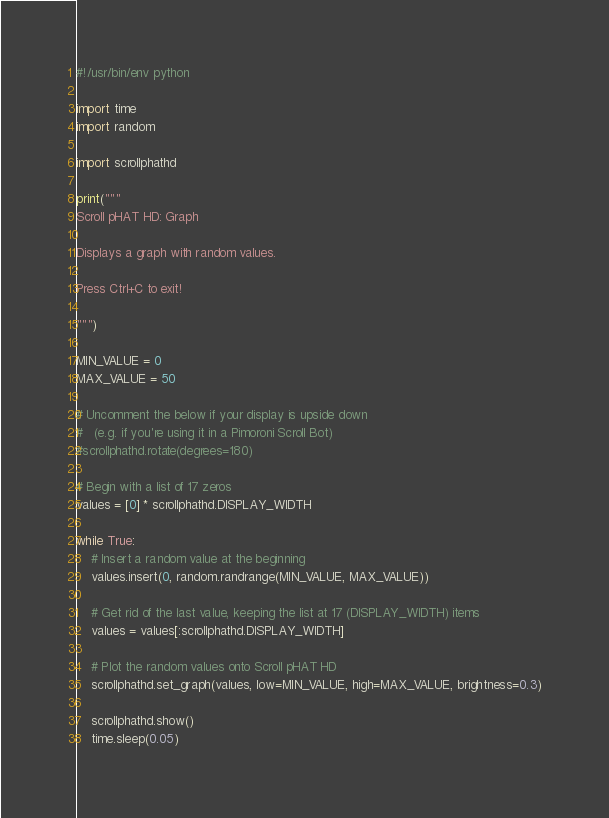Convert code to text. <code><loc_0><loc_0><loc_500><loc_500><_Python_>#!/usr/bin/env python

import time
import random

import scrollphathd

print("""
Scroll pHAT HD: Graph

Displays a graph with random values.

Press Ctrl+C to exit!

""")

MIN_VALUE = 0
MAX_VALUE = 50

# Uncomment the below if your display is upside down
#   (e.g. if you're using it in a Pimoroni Scroll Bot)
#scrollphathd.rotate(degrees=180)

# Begin with a list of 17 zeros
values = [0] * scrollphathd.DISPLAY_WIDTH

while True:
    # Insert a random value at the beginning
    values.insert(0, random.randrange(MIN_VALUE, MAX_VALUE))

    # Get rid of the last value, keeping the list at 17 (DISPLAY_WIDTH) items
    values = values[:scrollphathd.DISPLAY_WIDTH]

    # Plot the random values onto Scroll pHAT HD
    scrollphathd.set_graph(values, low=MIN_VALUE, high=MAX_VALUE, brightness=0.3)

    scrollphathd.show()
    time.sleep(0.05)
</code> 